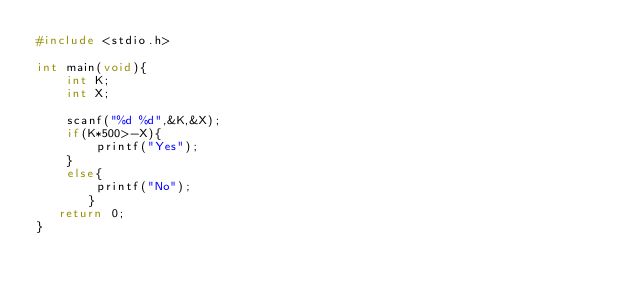<code> <loc_0><loc_0><loc_500><loc_500><_C_>#include <stdio.h>

int main(void){
    int K;
    int X;

    scanf("%d %d",&K,&X);
    if(K*500>-X){
        printf("Yes");
    }
    else{
        printf("No");
       }
   return 0;
}</code> 